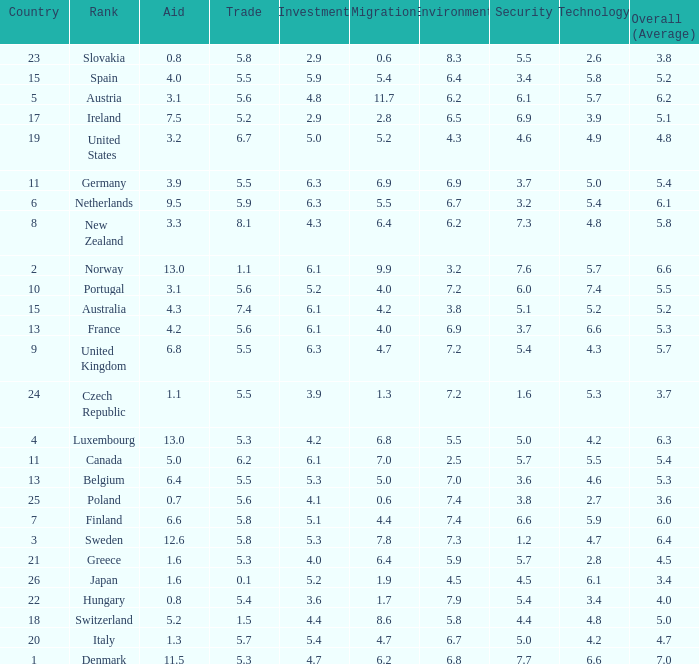How many times is denmark ranked in technology? 1.0. 